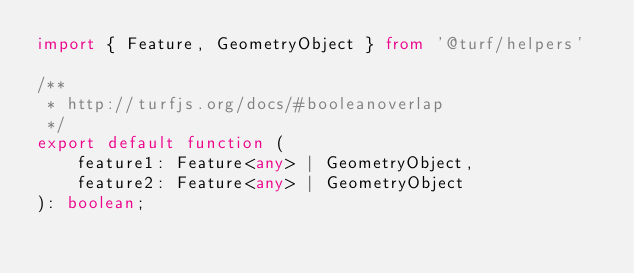Convert code to text. <code><loc_0><loc_0><loc_500><loc_500><_TypeScript_>import { Feature, GeometryObject } from '@turf/helpers'

/**
 * http://turfjs.org/docs/#booleanoverlap
 */
export default function (
    feature1: Feature<any> | GeometryObject,
    feature2: Feature<any> | GeometryObject
): boolean;
</code> 